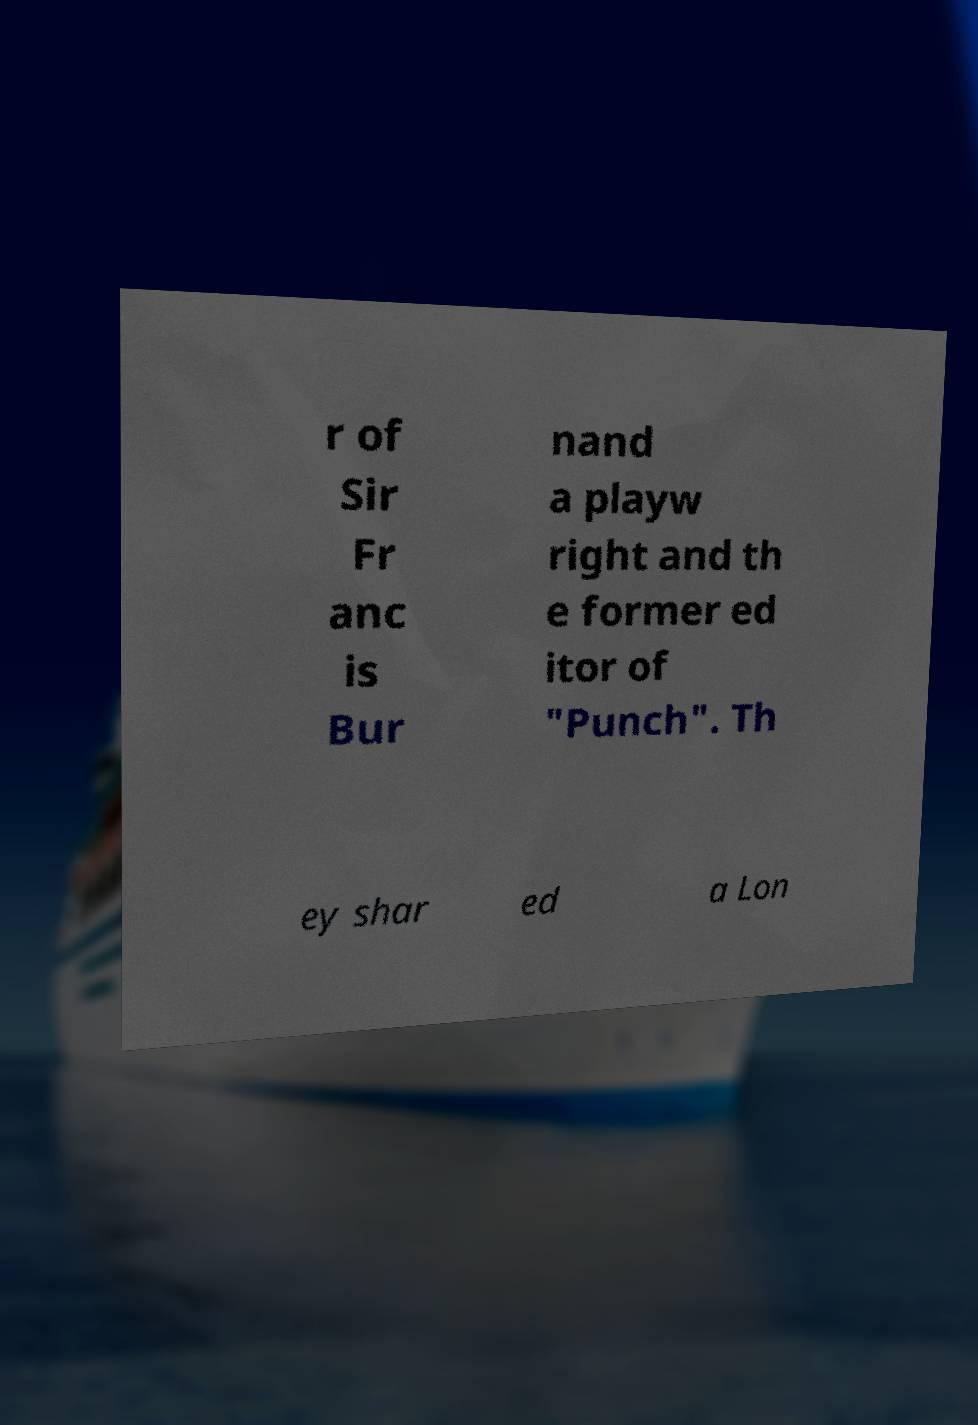Could you extract and type out the text from this image? r of Sir Fr anc is Bur nand a playw right and th e former ed itor of "Punch". Th ey shar ed a Lon 